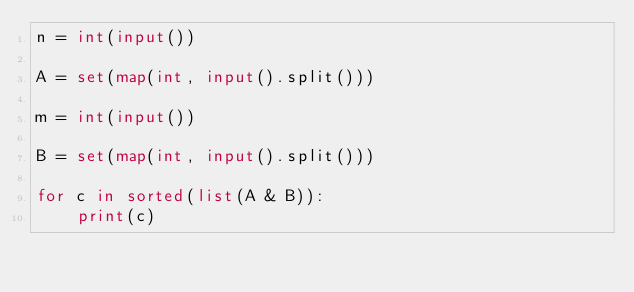<code> <loc_0><loc_0><loc_500><loc_500><_Python_>n = int(input())

A = set(map(int, input().split()))

m = int(input())

B = set(map(int, input().split()))

for c in sorted(list(A & B)):
    print(c)

</code> 